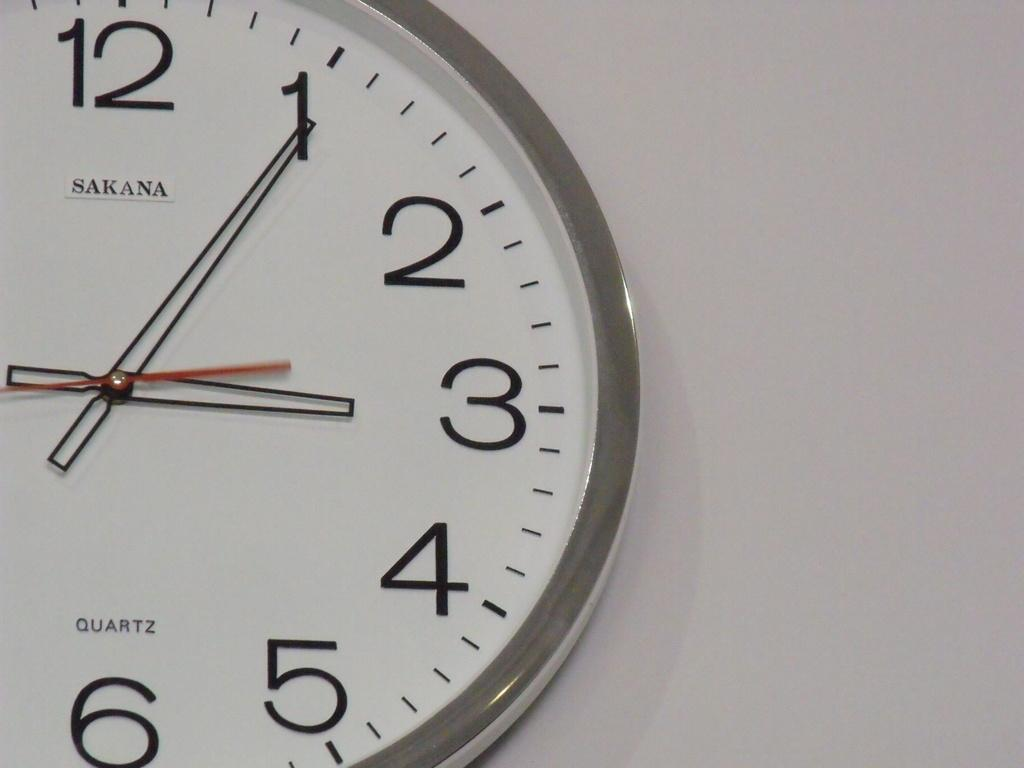<image>
Share a concise interpretation of the image provided. A clock on the wall with the number 3 showing. 